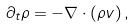Convert formula to latex. <formula><loc_0><loc_0><loc_500><loc_500>\partial _ { t } \rho = - \nabla \cdot ( \rho { v } ) \, ,</formula> 